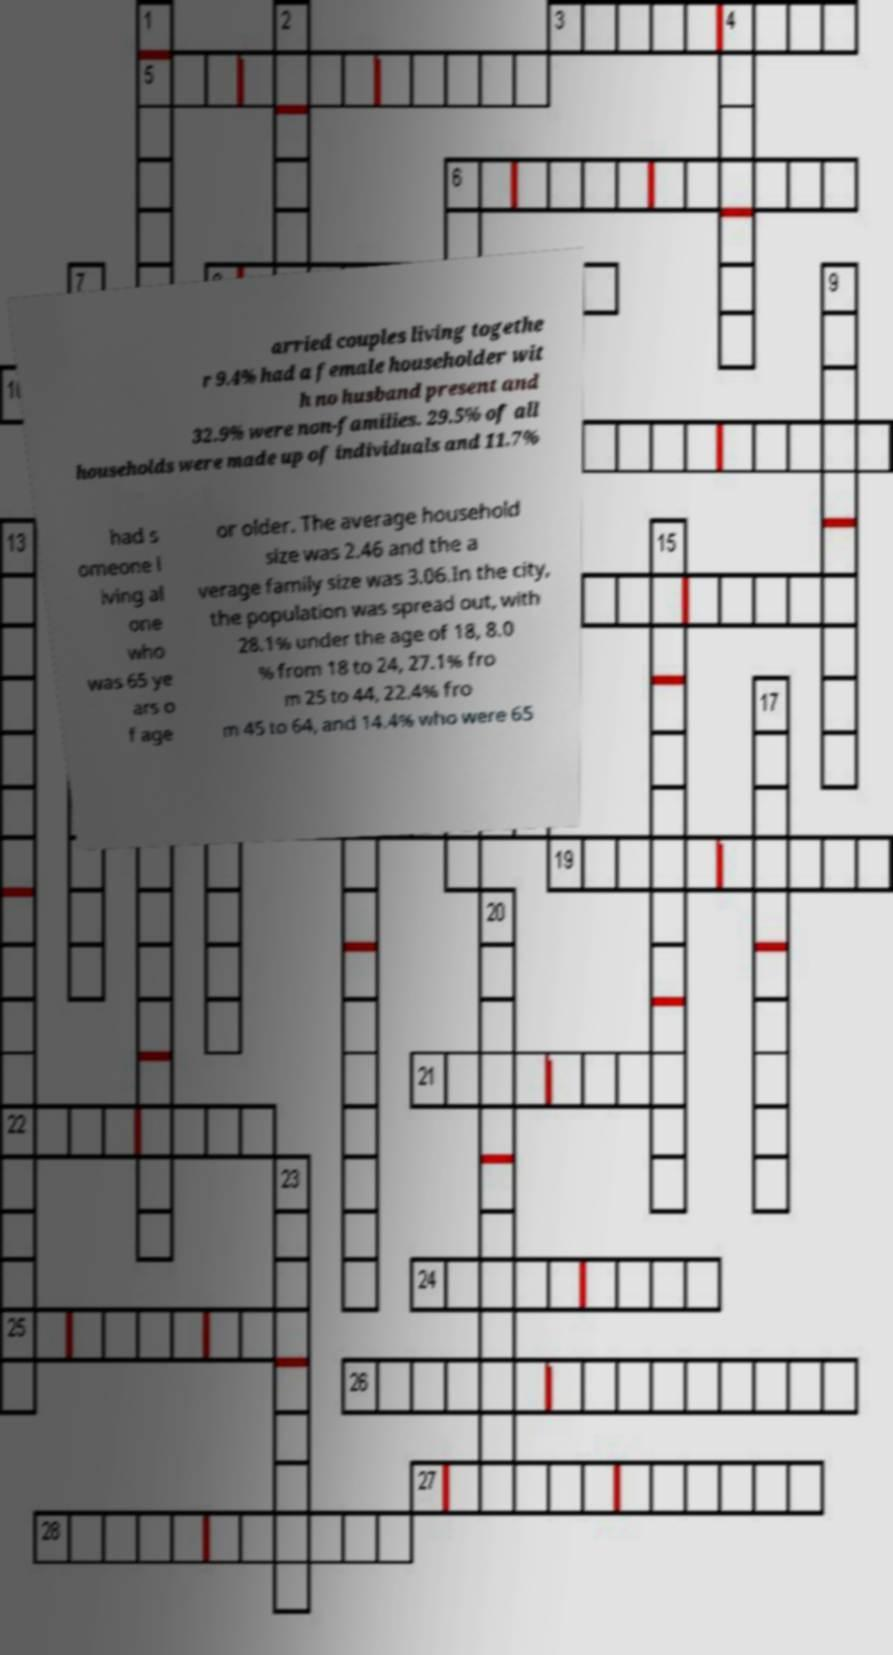Please identify and transcribe the text found in this image. arried couples living togethe r 9.4% had a female householder wit h no husband present and 32.9% were non-families. 29.5% of all households were made up of individuals and 11.7% had s omeone l iving al one who was 65 ye ars o f age or older. The average household size was 2.46 and the a verage family size was 3.06.In the city, the population was spread out, with 28.1% under the age of 18, 8.0 % from 18 to 24, 27.1% fro m 25 to 44, 22.4% fro m 45 to 64, and 14.4% who were 65 